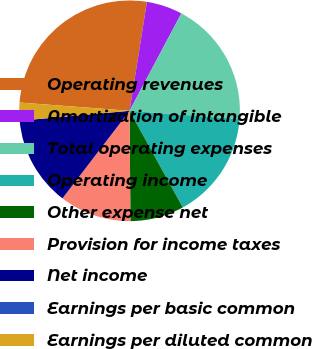<chart> <loc_0><loc_0><loc_500><loc_500><pie_chart><fcel>Operating revenues<fcel>Amortization of intangible<fcel>Total operating expenses<fcel>Operating income<fcel>Other expense net<fcel>Provision for income taxes<fcel>Net income<fcel>Earnings per basic common<fcel>Earnings per diluted common<nl><fcel>26.32%<fcel>5.26%<fcel>18.42%<fcel>15.79%<fcel>7.89%<fcel>10.53%<fcel>13.16%<fcel>0.0%<fcel>2.63%<nl></chart> 